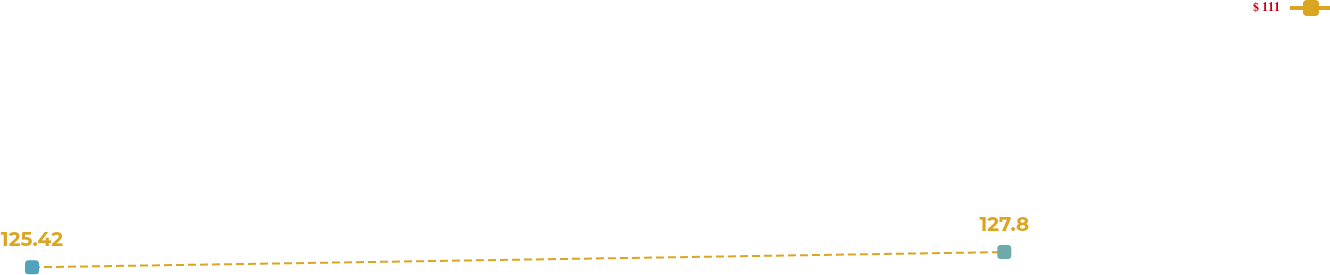Convert chart. <chart><loc_0><loc_0><loc_500><loc_500><line_chart><ecel><fcel>$ 111<nl><fcel>1845.75<fcel>125.42<nl><fcel>2186.07<fcel>127.8<nl><fcel>2251.2<fcel>150.06<nl><fcel>2293.76<fcel>147.68<nl></chart> 